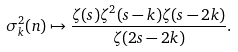Convert formula to latex. <formula><loc_0><loc_0><loc_500><loc_500>\sigma _ { k } ^ { 2 } ( n ) \mapsto \frac { \zeta ( s ) \zeta ^ { 2 } ( s - k ) \zeta ( s - 2 k ) } { \zeta ( 2 s - 2 k ) } .</formula> 